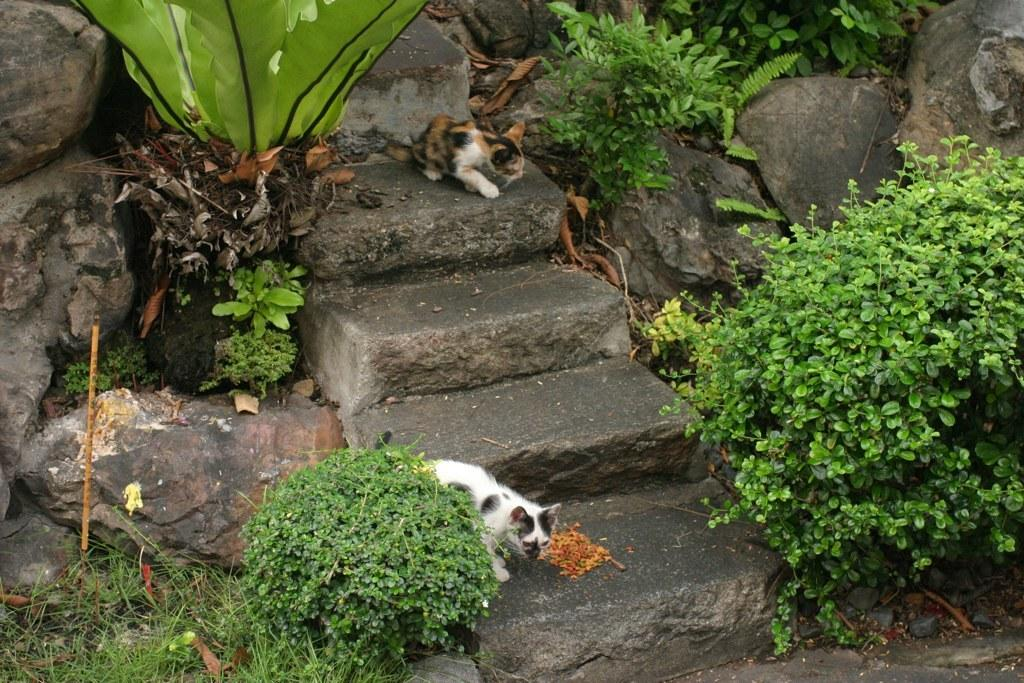What is located in the front of the image? There are plants in the front of the image. What animals can be seen in the image? There are cats on the steps in the image. What type of material is present in the background of the image? There are stones in the background of the image. What else can be seen in the background of the image besides stones? There are plants in the background of the image. What type of quartz can be seen on the shelf in the image? There is no quartz or shelf present in the image. How many kitties are playing on the steps in the image? There is no mention of the number of cats in the image, only that there are cats on the steps. 